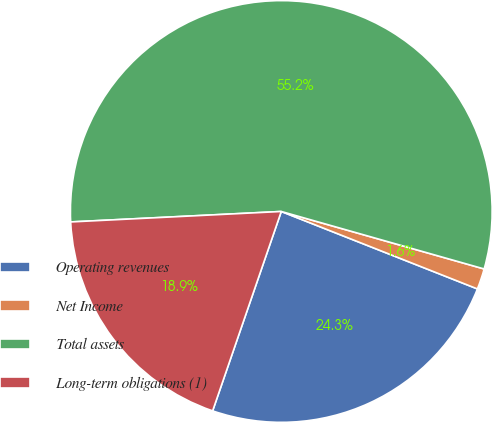Convert chart. <chart><loc_0><loc_0><loc_500><loc_500><pie_chart><fcel>Operating revenues<fcel>Net Income<fcel>Total assets<fcel>Long-term obligations (1)<nl><fcel>24.29%<fcel>1.59%<fcel>55.18%<fcel>18.93%<nl></chart> 